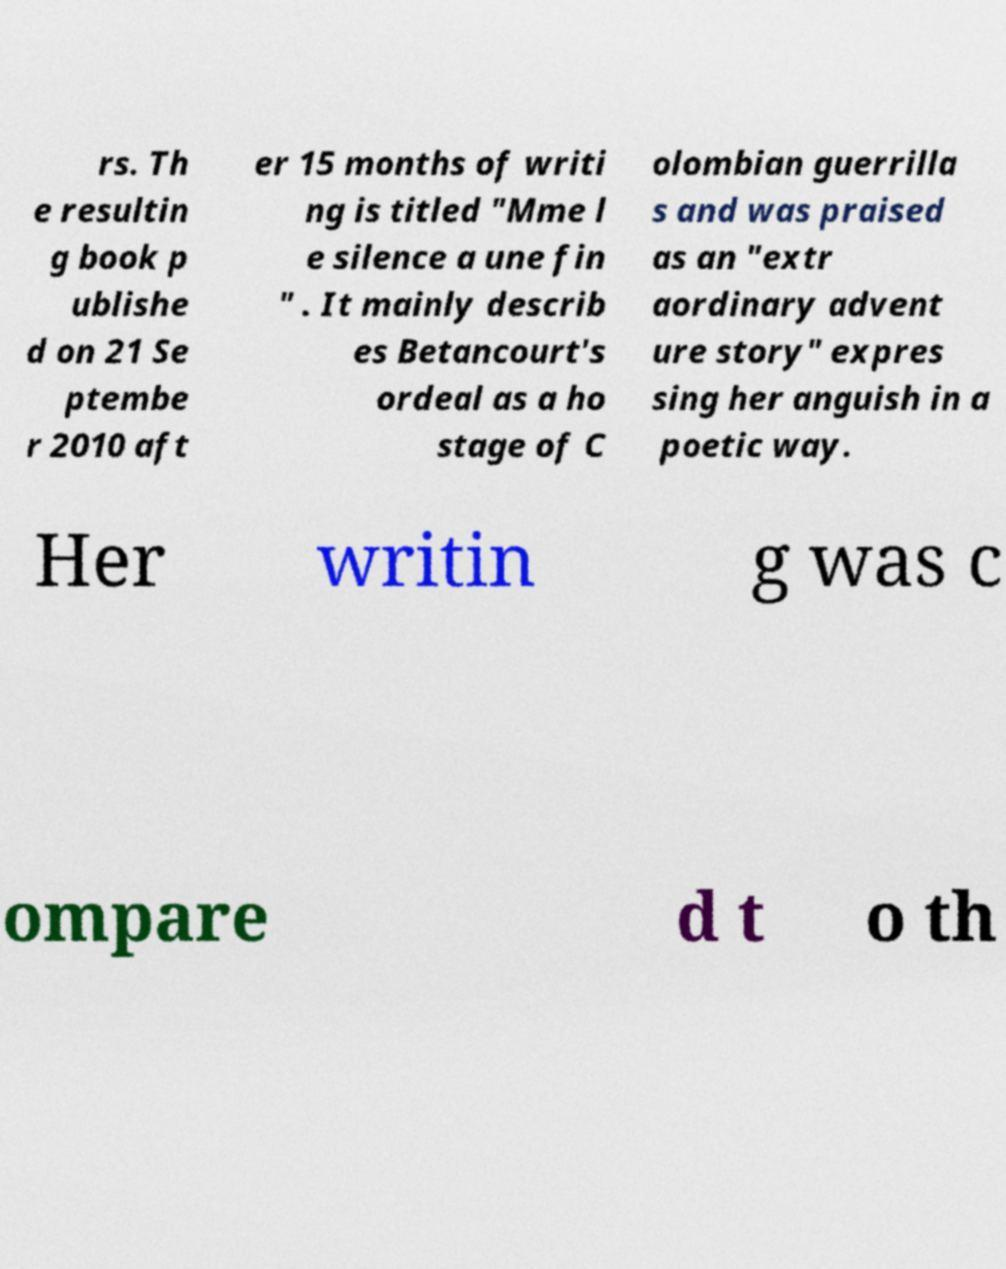Can you accurately transcribe the text from the provided image for me? rs. Th e resultin g book p ublishe d on 21 Se ptembe r 2010 aft er 15 months of writi ng is titled "Mme l e silence a une fin " . It mainly describ es Betancourt's ordeal as a ho stage of C olombian guerrilla s and was praised as an "extr aordinary advent ure story" expres sing her anguish in a poetic way. Her writin g was c ompare d t o th 